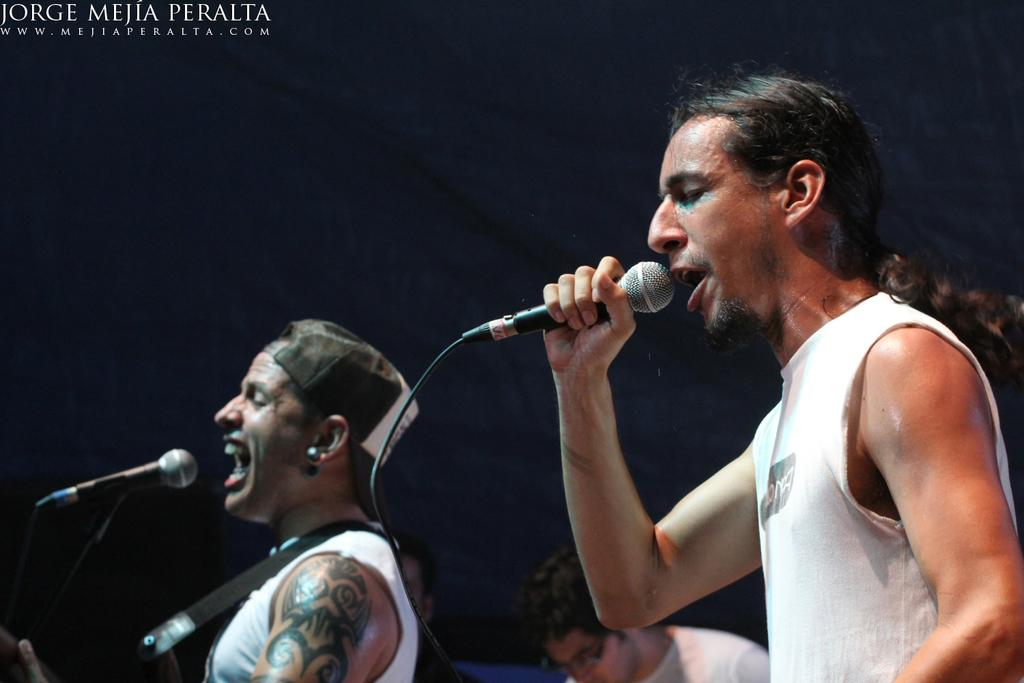Who is the main subject in the picture? There is a man in the picture. What is the man doing in the image? The man is standing and appears to be singing. What object is the man holding in his hands? The man is holding a microphone in his hands. What type of alarm can be heard in the background of the image? There is no alarm present in the image, as it is a picture of a man singing with a microphone. Can you see a tiger in the image? No, there is no tiger present in the image. 